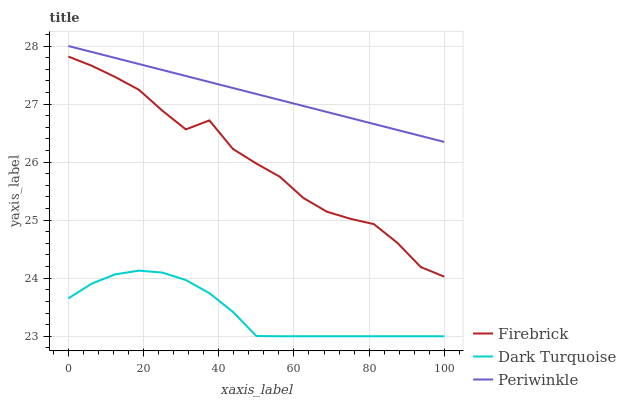Does Dark Turquoise have the minimum area under the curve?
Answer yes or no. Yes. Does Periwinkle have the maximum area under the curve?
Answer yes or no. Yes. Does Firebrick have the minimum area under the curve?
Answer yes or no. No. Does Firebrick have the maximum area under the curve?
Answer yes or no. No. Is Periwinkle the smoothest?
Answer yes or no. Yes. Is Firebrick the roughest?
Answer yes or no. Yes. Is Firebrick the smoothest?
Answer yes or no. No. Is Periwinkle the roughest?
Answer yes or no. No. Does Dark Turquoise have the lowest value?
Answer yes or no. Yes. Does Firebrick have the lowest value?
Answer yes or no. No. Does Periwinkle have the highest value?
Answer yes or no. Yes. Does Firebrick have the highest value?
Answer yes or no. No. Is Dark Turquoise less than Firebrick?
Answer yes or no. Yes. Is Periwinkle greater than Firebrick?
Answer yes or no. Yes. Does Dark Turquoise intersect Firebrick?
Answer yes or no. No. 